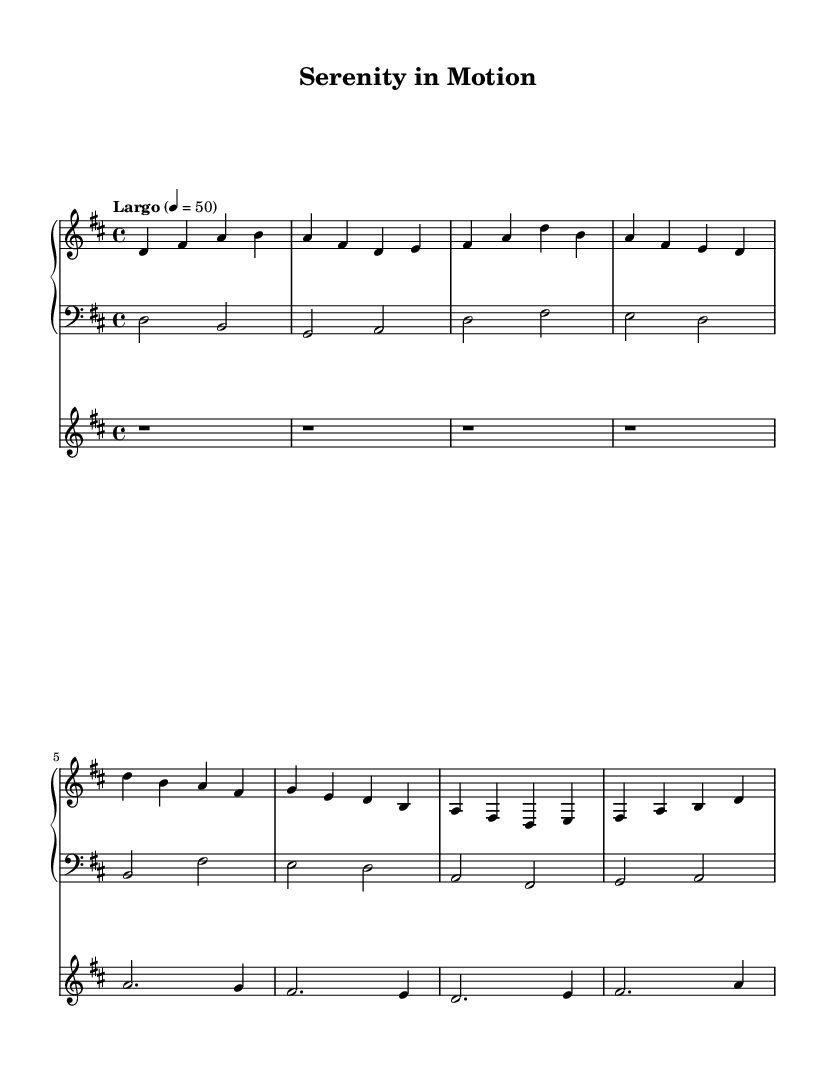What is the key signature of this music? The key signature is indicated at the beginning of the staff and shows two sharps, which corresponds to D major.
Answer: D major What is the time signature of this music? The time signature is shown at the beginning of the score, indicating that there are four beats in each measure.
Answer: 4/4 What tempo marking is used in this piece? The tempo marking "Largo" is found at the start, specifying a slow pace, and the metronome marking of 50 beats per minute is indicated.
Answer: Largo How many measures are in the piano part? By counting the distinct groups of notes separated by vertical bars, we find there are a total of eight measures in the piano part.
Answer: 8 Which instrument has a rest on the first four measures? The synthesizer part shows a rest for the first four measures, represented by the "r" symbol in the staff.
Answer: Synthesizer What kind of fusion does this music represent? The combination of ambient and classical elements is evident in the style and instrumentation used in the music score.
Answer: Ambient-classical fusion What is the highest note played in the synthesizer part? Looking at the synthesizer part, the highest note indicated is 'a' in the second measure, which is the only note played in that part.
Answer: A 